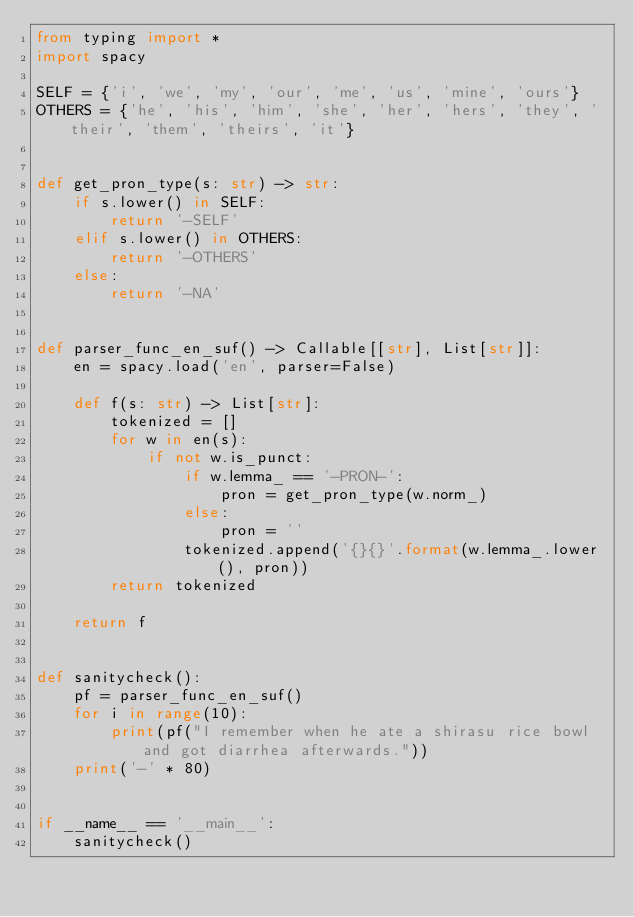<code> <loc_0><loc_0><loc_500><loc_500><_Python_>from typing import *
import spacy

SELF = {'i', 'we', 'my', 'our', 'me', 'us', 'mine', 'ours'}
OTHERS = {'he', 'his', 'him', 'she', 'her', 'hers', 'they', 'their', 'them', 'theirs', 'it'}


def get_pron_type(s: str) -> str:
    if s.lower() in SELF:
        return '-SELF'
    elif s.lower() in OTHERS:
        return '-OTHERS'
    else:
        return '-NA'


def parser_func_en_suf() -> Callable[[str], List[str]]:
    en = spacy.load('en', parser=False)

    def f(s: str) -> List[str]:
        tokenized = []
        for w in en(s):
            if not w.is_punct:
                if w.lemma_ == '-PRON-':
                    pron = get_pron_type(w.norm_)
                else:
                    pron = ''
                tokenized.append('{}{}'.format(w.lemma_.lower(), pron))
        return tokenized

    return f


def sanitycheck():
    pf = parser_func_en_suf()
    for i in range(10):
        print(pf("I remember when he ate a shirasu rice bowl and got diarrhea afterwards."))
    print('-' * 80)


if __name__ == '__main__':
    sanitycheck()
</code> 